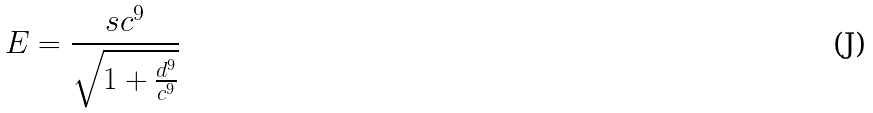Convert formula to latex. <formula><loc_0><loc_0><loc_500><loc_500>E = \frac { s c ^ { 9 } } { \sqrt { 1 + \frac { d ^ { 9 } } { c ^ { 9 } } } }</formula> 